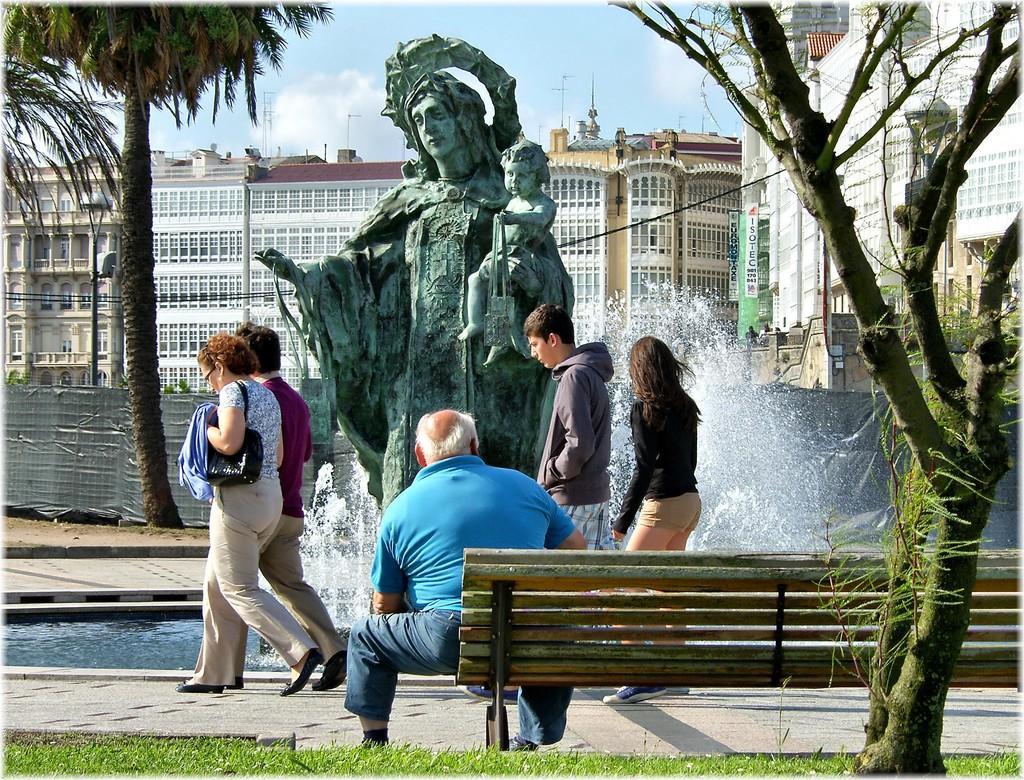How would you summarize this image in a sentence or two? In the image there were five peoples,the four people were walking on the road and the center the man is sitting on the bench. And in front of them there is a statue, fountain and back of the statue there is a building in white color with red roof. And the sky with clouds and they were some trees and grass. 